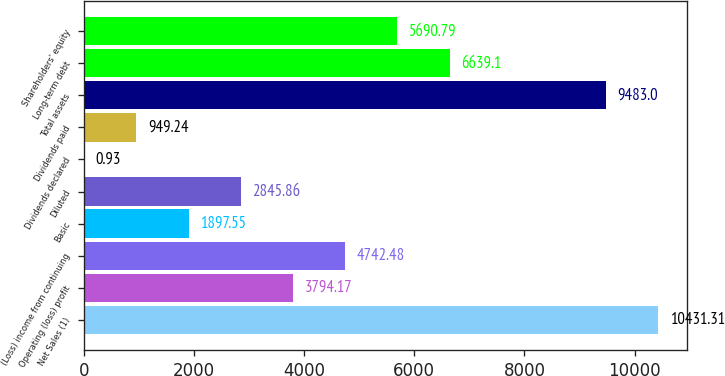<chart> <loc_0><loc_0><loc_500><loc_500><bar_chart><fcel>Net Sales (1)<fcel>Operating (loss) profit<fcel>(Loss) income from continuing<fcel>Basic<fcel>Diluted<fcel>Dividends declared<fcel>Dividends paid<fcel>Total assets<fcel>Long-term debt<fcel>Shareholders' equity<nl><fcel>10431.3<fcel>3794.17<fcel>4742.48<fcel>1897.55<fcel>2845.86<fcel>0.93<fcel>949.24<fcel>9483<fcel>6639.1<fcel>5690.79<nl></chart> 